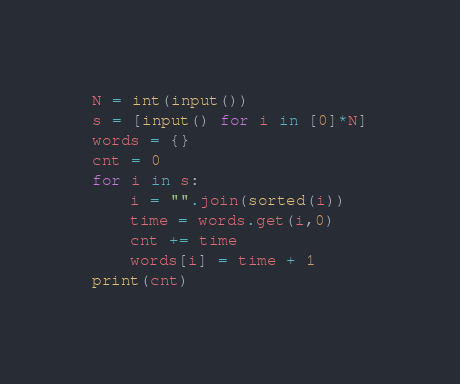<code> <loc_0><loc_0><loc_500><loc_500><_Python_>N = int(input())
s = [input() for i in [0]*N]
words = {}
cnt = 0
for i in s:
    i = "".join(sorted(i))
    time = words.get(i,0)
    cnt += time
    words[i] = time + 1
print(cnt)
</code> 